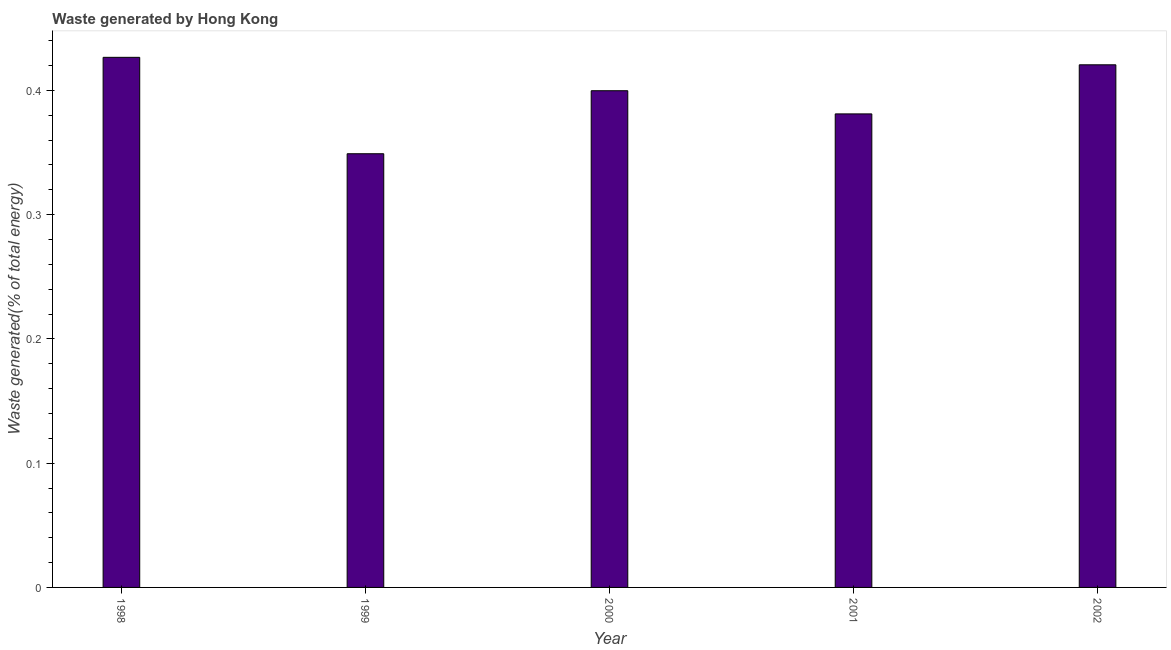Does the graph contain any zero values?
Give a very brief answer. No. What is the title of the graph?
Ensure brevity in your answer.  Waste generated by Hong Kong. What is the label or title of the Y-axis?
Provide a short and direct response. Waste generated(% of total energy). What is the amount of waste generated in 2000?
Keep it short and to the point. 0.4. Across all years, what is the maximum amount of waste generated?
Ensure brevity in your answer.  0.43. Across all years, what is the minimum amount of waste generated?
Give a very brief answer. 0.35. In which year was the amount of waste generated maximum?
Provide a short and direct response. 1998. In which year was the amount of waste generated minimum?
Your answer should be very brief. 1999. What is the sum of the amount of waste generated?
Keep it short and to the point. 1.98. What is the difference between the amount of waste generated in 1999 and 2001?
Provide a succinct answer. -0.03. What is the average amount of waste generated per year?
Your response must be concise. 0.4. What is the median amount of waste generated?
Your answer should be compact. 0.4. In how many years, is the amount of waste generated greater than 0.38 %?
Your answer should be compact. 4. What is the ratio of the amount of waste generated in 1999 to that in 2002?
Ensure brevity in your answer.  0.83. Is the amount of waste generated in 1999 less than that in 2001?
Provide a succinct answer. Yes. Is the difference between the amount of waste generated in 1999 and 2002 greater than the difference between any two years?
Ensure brevity in your answer.  No. What is the difference between the highest and the second highest amount of waste generated?
Offer a terse response. 0.01. Is the sum of the amount of waste generated in 2000 and 2002 greater than the maximum amount of waste generated across all years?
Offer a terse response. Yes. How many bars are there?
Your answer should be very brief. 5. What is the Waste generated(% of total energy) of 1998?
Offer a very short reply. 0.43. What is the Waste generated(% of total energy) in 1999?
Ensure brevity in your answer.  0.35. What is the Waste generated(% of total energy) in 2000?
Your answer should be very brief. 0.4. What is the Waste generated(% of total energy) of 2001?
Ensure brevity in your answer.  0.38. What is the Waste generated(% of total energy) of 2002?
Your answer should be compact. 0.42. What is the difference between the Waste generated(% of total energy) in 1998 and 1999?
Keep it short and to the point. 0.08. What is the difference between the Waste generated(% of total energy) in 1998 and 2000?
Offer a terse response. 0.03. What is the difference between the Waste generated(% of total energy) in 1998 and 2001?
Provide a short and direct response. 0.05. What is the difference between the Waste generated(% of total energy) in 1998 and 2002?
Give a very brief answer. 0.01. What is the difference between the Waste generated(% of total energy) in 1999 and 2000?
Offer a terse response. -0.05. What is the difference between the Waste generated(% of total energy) in 1999 and 2001?
Offer a very short reply. -0.03. What is the difference between the Waste generated(% of total energy) in 1999 and 2002?
Provide a short and direct response. -0.07. What is the difference between the Waste generated(% of total energy) in 2000 and 2001?
Ensure brevity in your answer.  0.02. What is the difference between the Waste generated(% of total energy) in 2000 and 2002?
Your answer should be compact. -0.02. What is the difference between the Waste generated(% of total energy) in 2001 and 2002?
Keep it short and to the point. -0.04. What is the ratio of the Waste generated(% of total energy) in 1998 to that in 1999?
Make the answer very short. 1.22. What is the ratio of the Waste generated(% of total energy) in 1998 to that in 2000?
Your answer should be compact. 1.07. What is the ratio of the Waste generated(% of total energy) in 1998 to that in 2001?
Your answer should be compact. 1.12. What is the ratio of the Waste generated(% of total energy) in 1999 to that in 2000?
Your answer should be compact. 0.87. What is the ratio of the Waste generated(% of total energy) in 1999 to that in 2001?
Provide a short and direct response. 0.92. What is the ratio of the Waste generated(% of total energy) in 1999 to that in 2002?
Your answer should be compact. 0.83. What is the ratio of the Waste generated(% of total energy) in 2000 to that in 2001?
Give a very brief answer. 1.05. What is the ratio of the Waste generated(% of total energy) in 2001 to that in 2002?
Give a very brief answer. 0.91. 